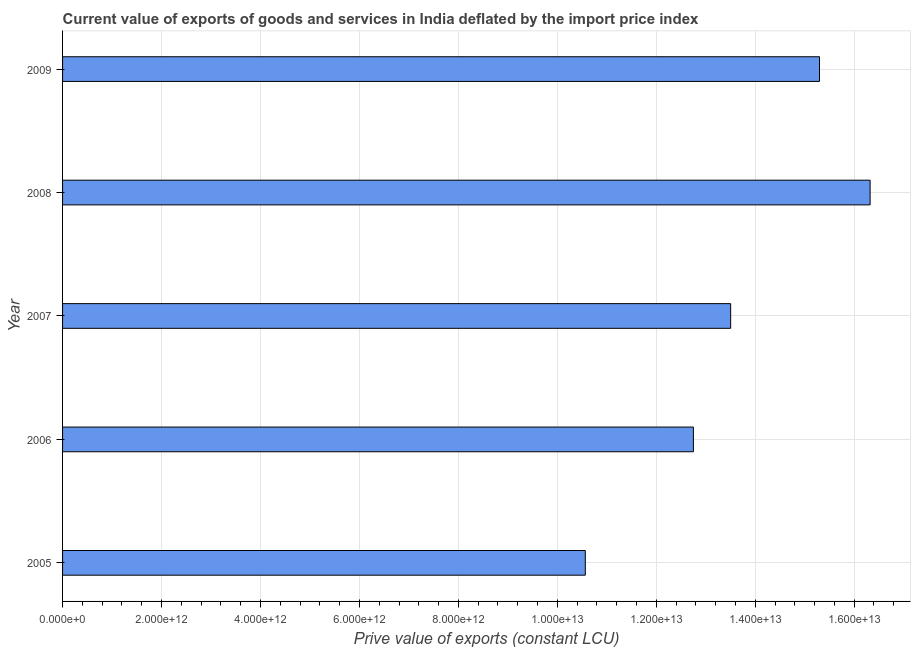What is the title of the graph?
Keep it short and to the point. Current value of exports of goods and services in India deflated by the import price index. What is the label or title of the X-axis?
Make the answer very short. Prive value of exports (constant LCU). What is the price value of exports in 2005?
Your response must be concise. 1.06e+13. Across all years, what is the maximum price value of exports?
Give a very brief answer. 1.63e+13. Across all years, what is the minimum price value of exports?
Give a very brief answer. 1.06e+13. In which year was the price value of exports maximum?
Provide a short and direct response. 2008. What is the sum of the price value of exports?
Provide a short and direct response. 6.84e+13. What is the difference between the price value of exports in 2007 and 2008?
Keep it short and to the point. -2.82e+12. What is the average price value of exports per year?
Make the answer very short. 1.37e+13. What is the median price value of exports?
Make the answer very short. 1.35e+13. In how many years, is the price value of exports greater than 3200000000000 LCU?
Provide a short and direct response. 5. What is the ratio of the price value of exports in 2008 to that in 2009?
Provide a succinct answer. 1.07. Is the price value of exports in 2005 less than that in 2007?
Give a very brief answer. Yes. Is the difference between the price value of exports in 2007 and 2009 greater than the difference between any two years?
Offer a terse response. No. What is the difference between the highest and the second highest price value of exports?
Your response must be concise. 1.02e+12. What is the difference between the highest and the lowest price value of exports?
Provide a succinct answer. 5.76e+12. How many bars are there?
Provide a short and direct response. 5. What is the difference between two consecutive major ticks on the X-axis?
Your answer should be very brief. 2.00e+12. Are the values on the major ticks of X-axis written in scientific E-notation?
Your answer should be very brief. Yes. What is the Prive value of exports (constant LCU) of 2005?
Ensure brevity in your answer.  1.06e+13. What is the Prive value of exports (constant LCU) of 2006?
Your response must be concise. 1.28e+13. What is the Prive value of exports (constant LCU) of 2007?
Ensure brevity in your answer.  1.35e+13. What is the Prive value of exports (constant LCU) of 2008?
Offer a very short reply. 1.63e+13. What is the Prive value of exports (constant LCU) in 2009?
Your answer should be very brief. 1.53e+13. What is the difference between the Prive value of exports (constant LCU) in 2005 and 2006?
Keep it short and to the point. -2.19e+12. What is the difference between the Prive value of exports (constant LCU) in 2005 and 2007?
Your response must be concise. -2.94e+12. What is the difference between the Prive value of exports (constant LCU) in 2005 and 2008?
Your response must be concise. -5.76e+12. What is the difference between the Prive value of exports (constant LCU) in 2005 and 2009?
Keep it short and to the point. -4.73e+12. What is the difference between the Prive value of exports (constant LCU) in 2006 and 2007?
Provide a succinct answer. -7.53e+11. What is the difference between the Prive value of exports (constant LCU) in 2006 and 2008?
Ensure brevity in your answer.  -3.57e+12. What is the difference between the Prive value of exports (constant LCU) in 2006 and 2009?
Your answer should be very brief. -2.55e+12. What is the difference between the Prive value of exports (constant LCU) in 2007 and 2008?
Your answer should be compact. -2.82e+12. What is the difference between the Prive value of exports (constant LCU) in 2007 and 2009?
Your answer should be very brief. -1.80e+12. What is the difference between the Prive value of exports (constant LCU) in 2008 and 2009?
Give a very brief answer. 1.02e+12. What is the ratio of the Prive value of exports (constant LCU) in 2005 to that in 2006?
Give a very brief answer. 0.83. What is the ratio of the Prive value of exports (constant LCU) in 2005 to that in 2007?
Provide a short and direct response. 0.78. What is the ratio of the Prive value of exports (constant LCU) in 2005 to that in 2008?
Your answer should be compact. 0.65. What is the ratio of the Prive value of exports (constant LCU) in 2005 to that in 2009?
Offer a terse response. 0.69. What is the ratio of the Prive value of exports (constant LCU) in 2006 to that in 2007?
Ensure brevity in your answer.  0.94. What is the ratio of the Prive value of exports (constant LCU) in 2006 to that in 2008?
Give a very brief answer. 0.78. What is the ratio of the Prive value of exports (constant LCU) in 2006 to that in 2009?
Provide a succinct answer. 0.83. What is the ratio of the Prive value of exports (constant LCU) in 2007 to that in 2008?
Make the answer very short. 0.83. What is the ratio of the Prive value of exports (constant LCU) in 2007 to that in 2009?
Your answer should be compact. 0.88. What is the ratio of the Prive value of exports (constant LCU) in 2008 to that in 2009?
Your answer should be very brief. 1.07. 